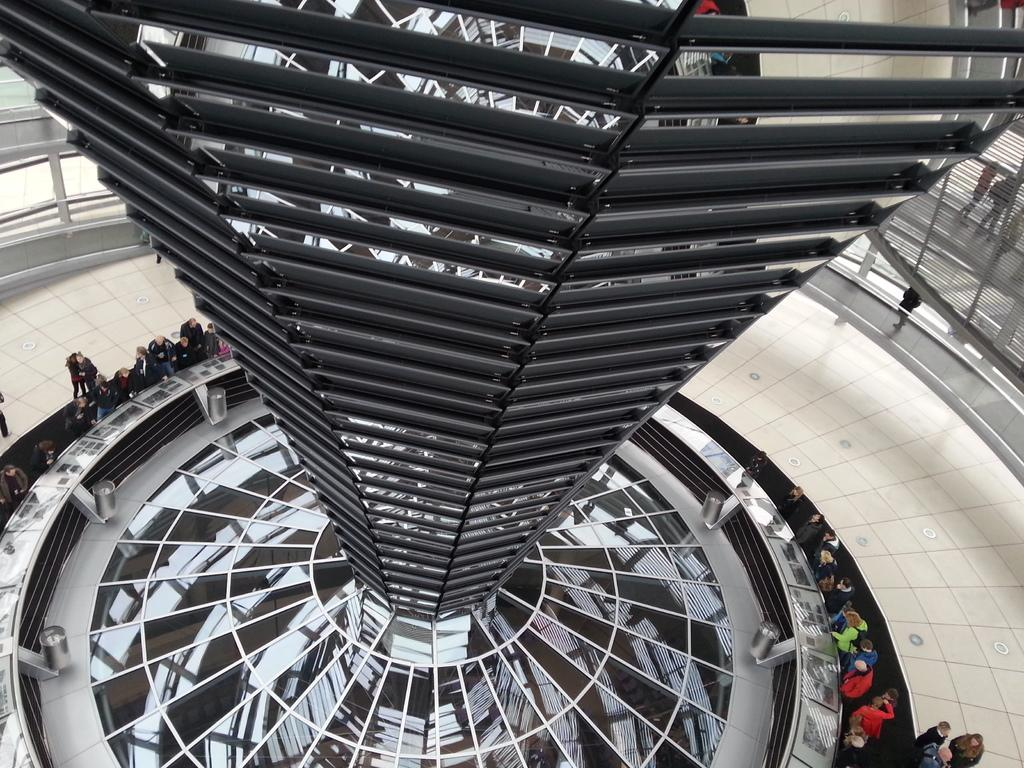What is the setting of the image? The image shows the inside of a building. Can you describe any specific objects in the image? There is a metallic object in the image. What is the position of the group of persons in the image? The group of persons is on the floor in the image. What type of poison is being used by the group of persons in the image? There is no indication of poison or any such substance being used in the image. 